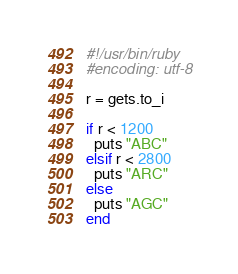<code> <loc_0><loc_0><loc_500><loc_500><_Ruby_>#!/usr/bin/ruby 
#encoding: utf-8

r = gets.to_i

if r < 1200
  puts "ABC"
elsif r < 2800
  puts "ARC"
else
  puts "AGC"
end
</code> 